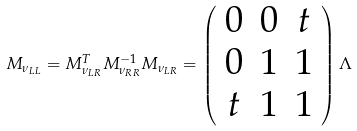Convert formula to latex. <formula><loc_0><loc_0><loc_500><loc_500>M _ { \nu _ { L L } } = M _ { \nu _ { L R } } ^ { T } M _ { \nu _ { R R } } ^ { - 1 } M _ { \nu _ { L R } } = \left ( \begin{array} { c c c } 0 & 0 & t \\ 0 & 1 & 1 \\ t & 1 & 1 \end{array} \right ) \Lambda</formula> 